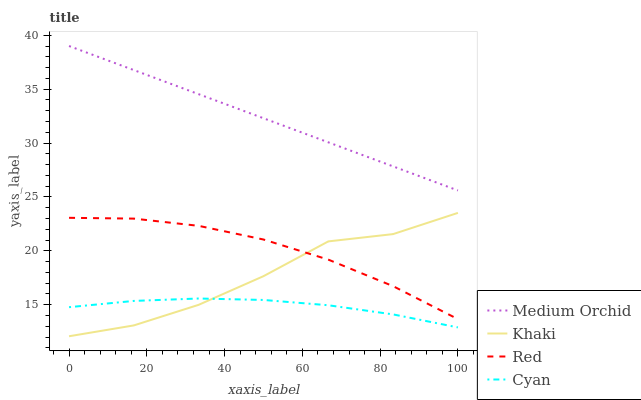Does Cyan have the minimum area under the curve?
Answer yes or no. Yes. Does Medium Orchid have the maximum area under the curve?
Answer yes or no. Yes. Does Khaki have the minimum area under the curve?
Answer yes or no. No. Does Khaki have the maximum area under the curve?
Answer yes or no. No. Is Medium Orchid the smoothest?
Answer yes or no. Yes. Is Khaki the roughest?
Answer yes or no. Yes. Is Khaki the smoothest?
Answer yes or no. No. Is Medium Orchid the roughest?
Answer yes or no. No. Does Khaki have the lowest value?
Answer yes or no. Yes. Does Medium Orchid have the lowest value?
Answer yes or no. No. Does Medium Orchid have the highest value?
Answer yes or no. Yes. Does Khaki have the highest value?
Answer yes or no. No. Is Khaki less than Medium Orchid?
Answer yes or no. Yes. Is Red greater than Cyan?
Answer yes or no. Yes. Does Khaki intersect Red?
Answer yes or no. Yes. Is Khaki less than Red?
Answer yes or no. No. Is Khaki greater than Red?
Answer yes or no. No. Does Khaki intersect Medium Orchid?
Answer yes or no. No. 